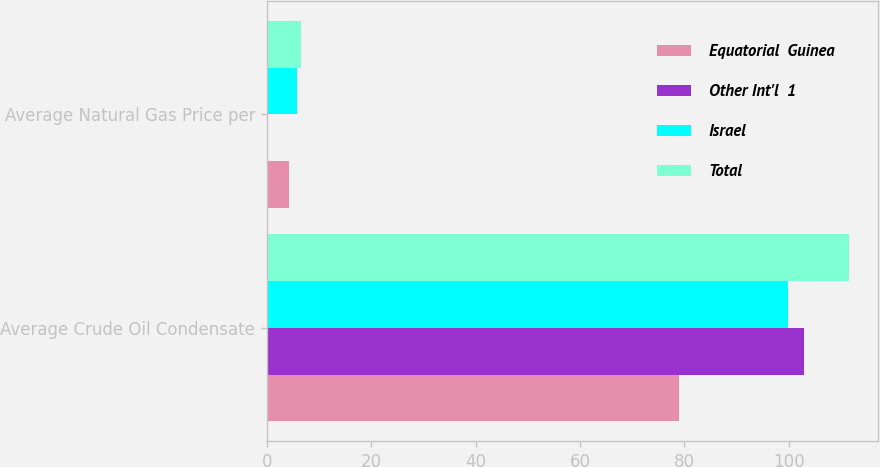Convert chart to OTSL. <chart><loc_0><loc_0><loc_500><loc_500><stacked_bar_chart><ecel><fcel>Average Crude Oil Condensate<fcel>Average Natural Gas Price per<nl><fcel>Equatorial  Guinea<fcel>78.9<fcel>4.24<nl><fcel>Other Int'l  1<fcel>103.01<fcel>0.25<nl><fcel>Israel<fcel>99.92<fcel>5.85<nl><fcel>Total<fcel>111.5<fcel>6.55<nl></chart> 